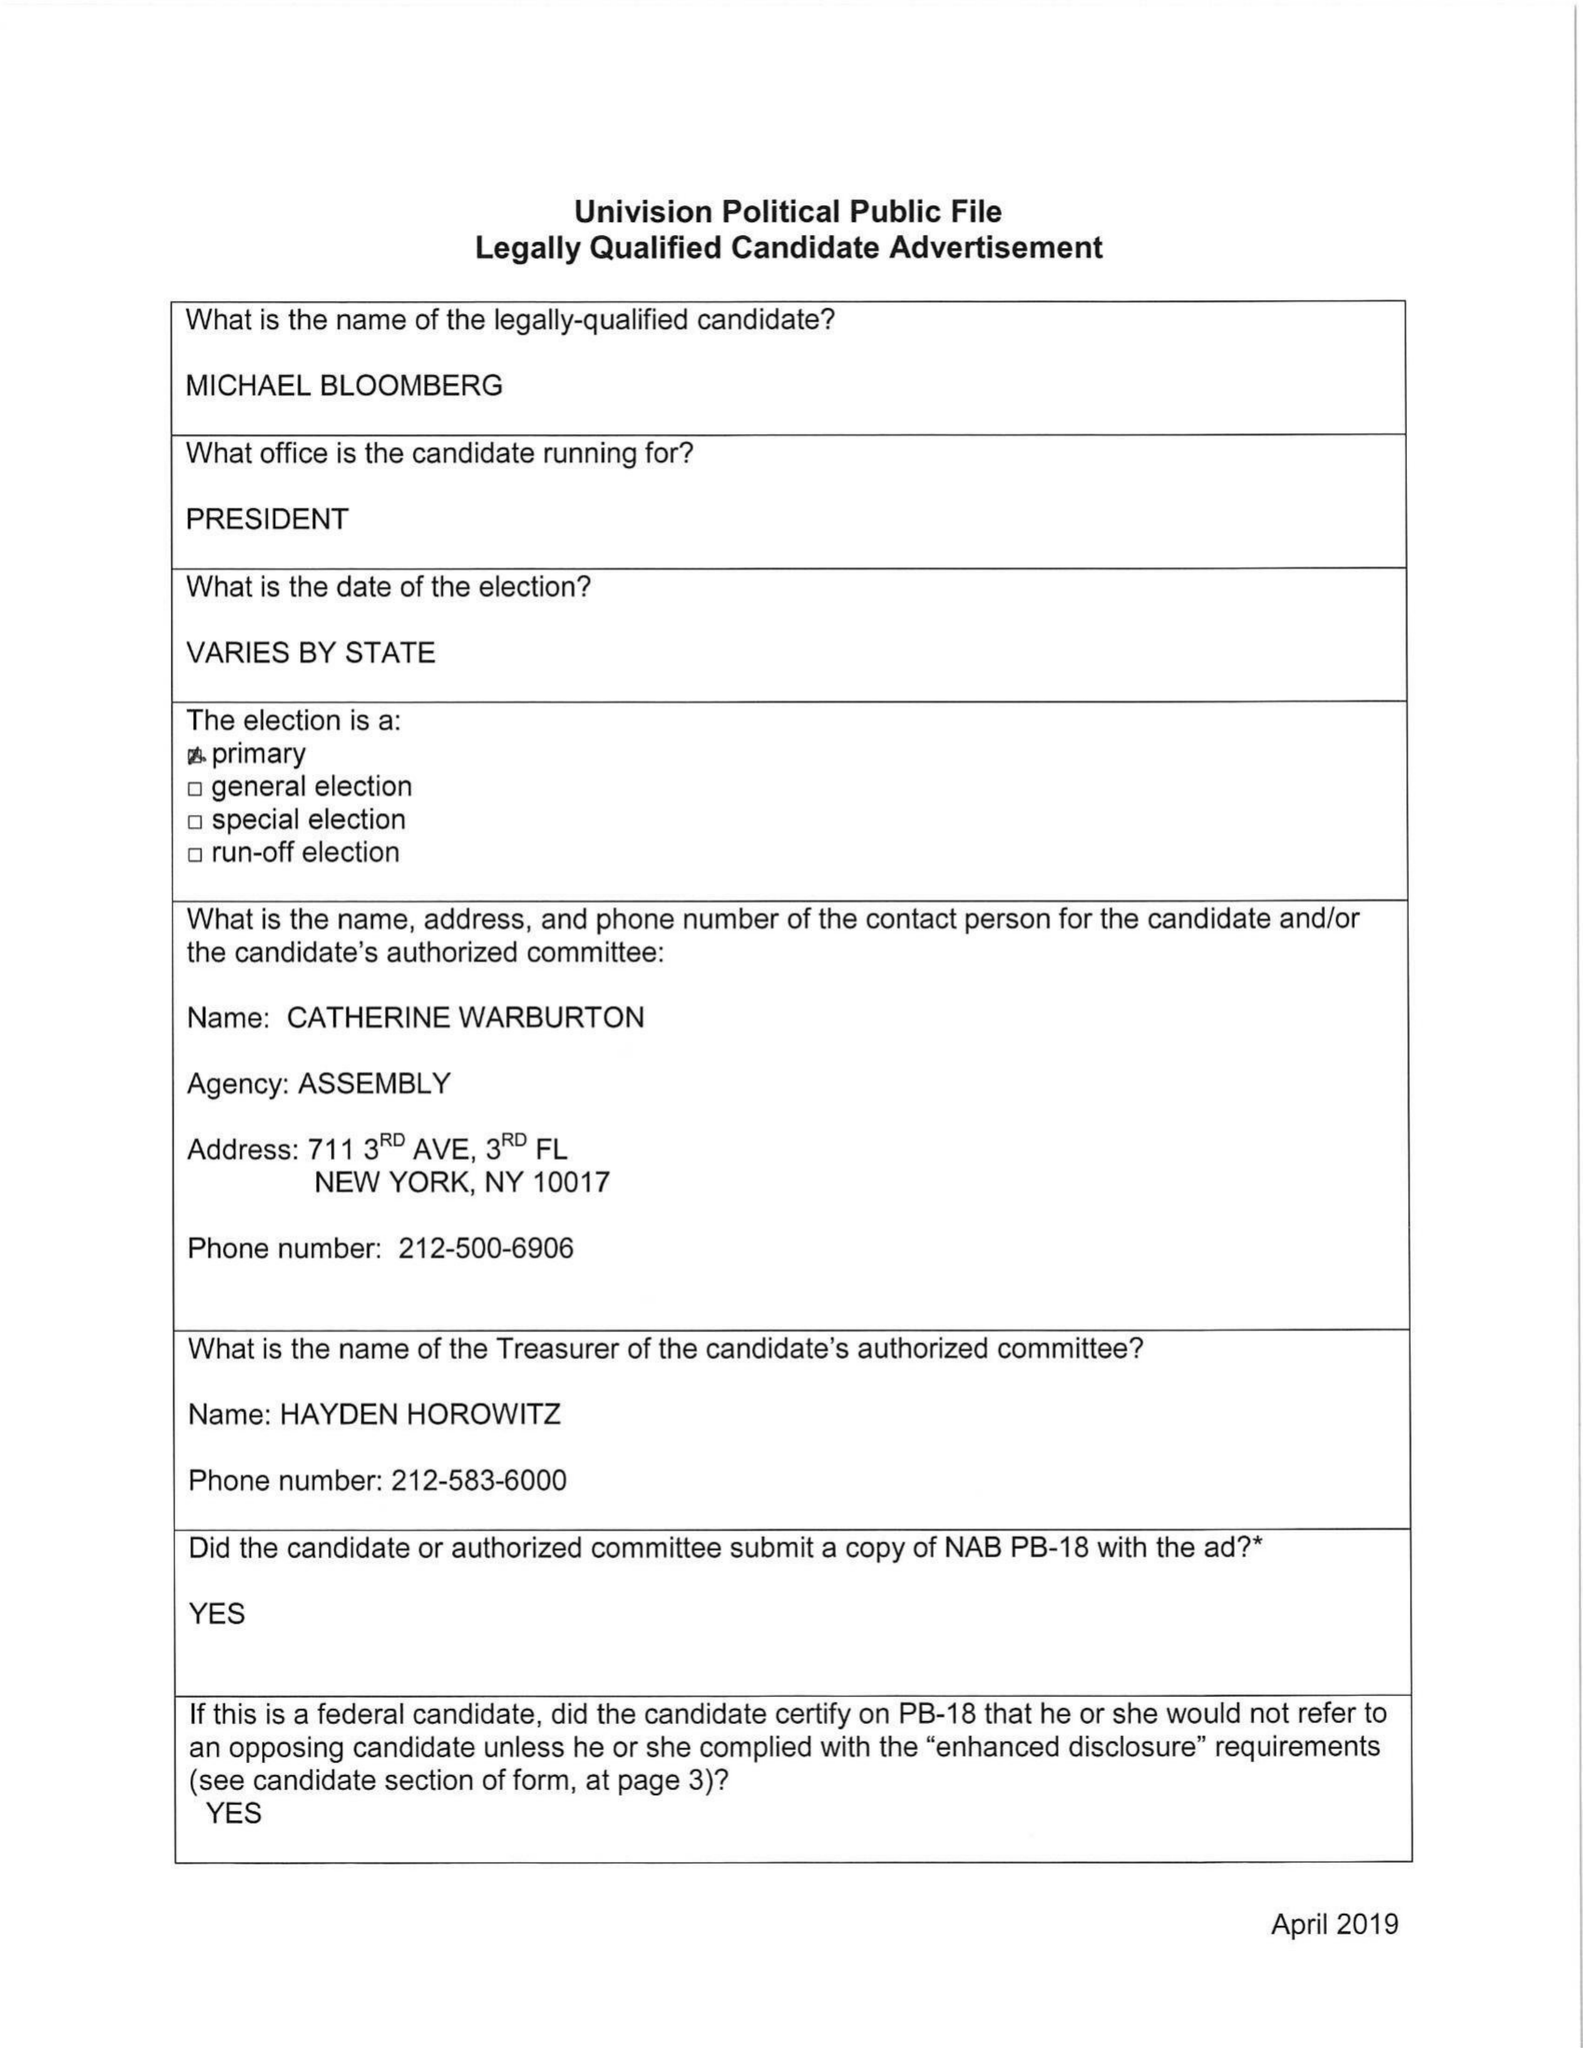What is the value for the flight_to?
Answer the question using a single word or phrase. None 